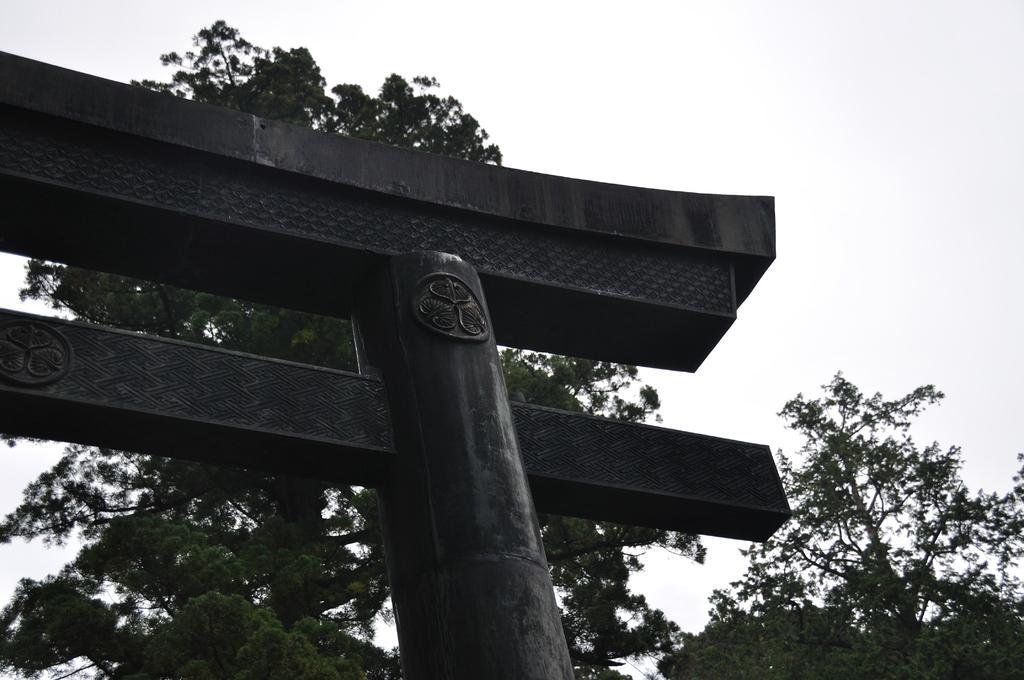Please provide a concise description of this image. In this image we can see a arch. In the background of the image there is sky and trees. 